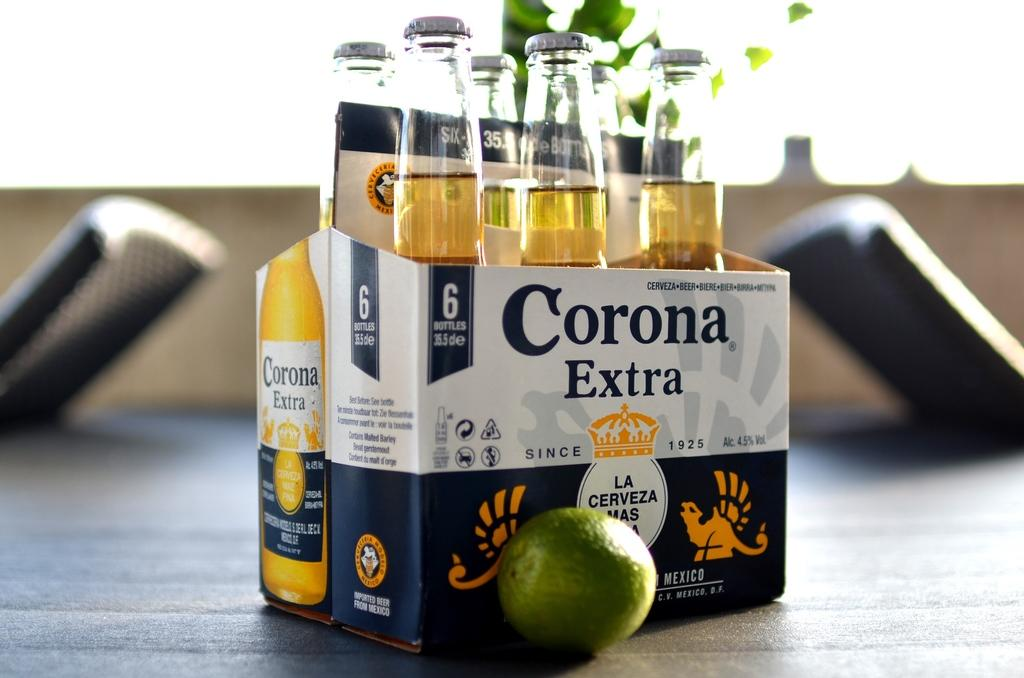What is contained within the box in the image? There are bottles in a box in the image. Can you describe the box itself? The box has text and images on it. What is the surface beneath the box? There is a ground visible in the image. What else can be seen on the ground? There are objects on the ground. What type of food is visible in the image? There is a fruit visible in the image. What can be seen behind the box and objects on the ground? The background of the image is visible. How many bikes are participating in the voyage depicted in the image? There are no bikes or voyages depicted in the image; it features bottles in a box, a ground, objects, a fruit, and a background. 